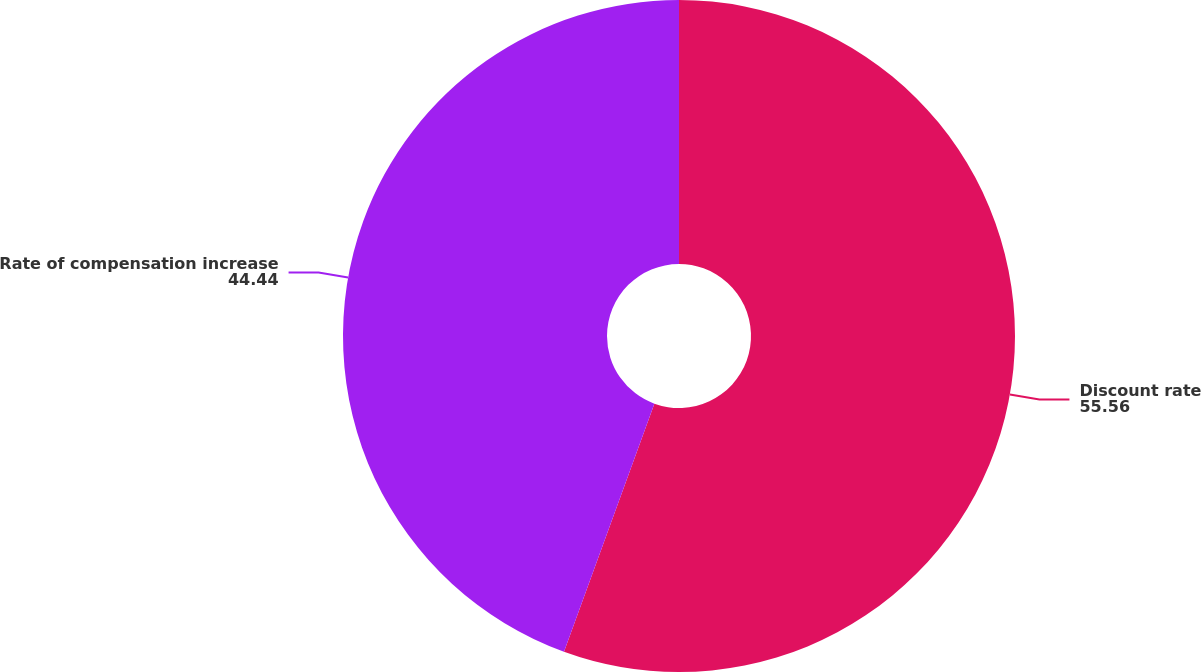Convert chart. <chart><loc_0><loc_0><loc_500><loc_500><pie_chart><fcel>Discount rate<fcel>Rate of compensation increase<nl><fcel>55.56%<fcel>44.44%<nl></chart> 